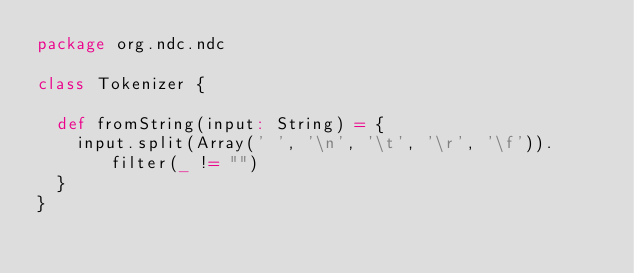<code> <loc_0><loc_0><loc_500><loc_500><_Scala_>package org.ndc.ndc

class Tokenizer {

  def fromString(input: String) = {
    input.split(Array(' ', '\n', '\t', '\r', '\f')).filter(_ != "")
  }
}</code> 